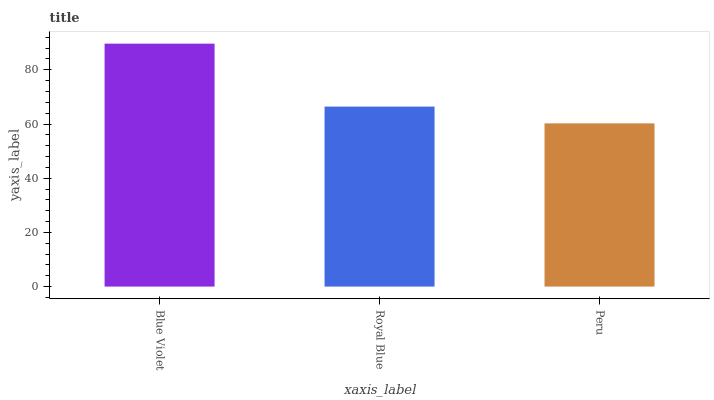Is Peru the minimum?
Answer yes or no. Yes. Is Blue Violet the maximum?
Answer yes or no. Yes. Is Royal Blue the minimum?
Answer yes or no. No. Is Royal Blue the maximum?
Answer yes or no. No. Is Blue Violet greater than Royal Blue?
Answer yes or no. Yes. Is Royal Blue less than Blue Violet?
Answer yes or no. Yes. Is Royal Blue greater than Blue Violet?
Answer yes or no. No. Is Blue Violet less than Royal Blue?
Answer yes or no. No. Is Royal Blue the high median?
Answer yes or no. Yes. Is Royal Blue the low median?
Answer yes or no. Yes. Is Blue Violet the high median?
Answer yes or no. No. Is Peru the low median?
Answer yes or no. No. 